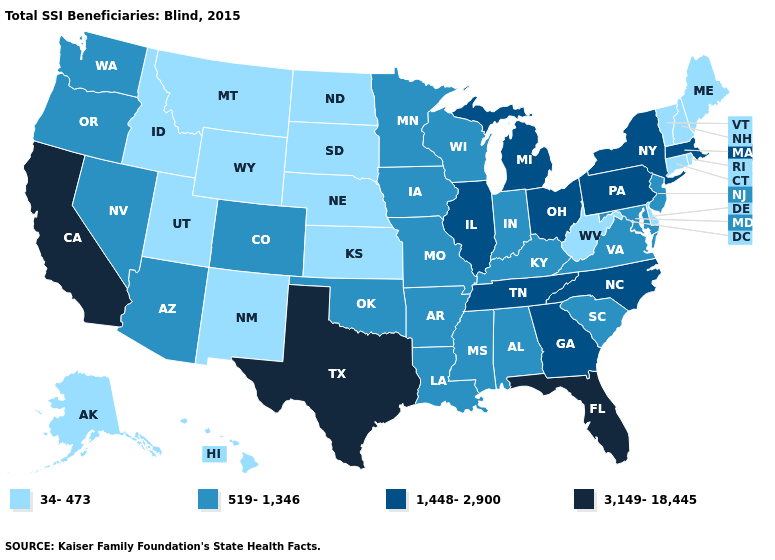Does the map have missing data?
Keep it brief. No. What is the lowest value in states that border Missouri?
Answer briefly. 34-473. What is the highest value in the USA?
Be succinct. 3,149-18,445. What is the value of Kansas?
Concise answer only. 34-473. What is the lowest value in the MidWest?
Concise answer only. 34-473. What is the value of New York?
Answer briefly. 1,448-2,900. Name the states that have a value in the range 34-473?
Be succinct. Alaska, Connecticut, Delaware, Hawaii, Idaho, Kansas, Maine, Montana, Nebraska, New Hampshire, New Mexico, North Dakota, Rhode Island, South Dakota, Utah, Vermont, West Virginia, Wyoming. Name the states that have a value in the range 34-473?
Concise answer only. Alaska, Connecticut, Delaware, Hawaii, Idaho, Kansas, Maine, Montana, Nebraska, New Hampshire, New Mexico, North Dakota, Rhode Island, South Dakota, Utah, Vermont, West Virginia, Wyoming. What is the value of Michigan?
Write a very short answer. 1,448-2,900. Which states hav the highest value in the Northeast?
Quick response, please. Massachusetts, New York, Pennsylvania. Among the states that border Kansas , does Missouri have the lowest value?
Be succinct. No. What is the value of Maryland?
Write a very short answer. 519-1,346. What is the highest value in states that border Utah?
Quick response, please. 519-1,346. What is the value of Wisconsin?
Answer briefly. 519-1,346. 